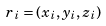Convert formula to latex. <formula><loc_0><loc_0><loc_500><loc_500>r _ { i } = ( x _ { i } , y _ { i } , z _ { i } )</formula> 